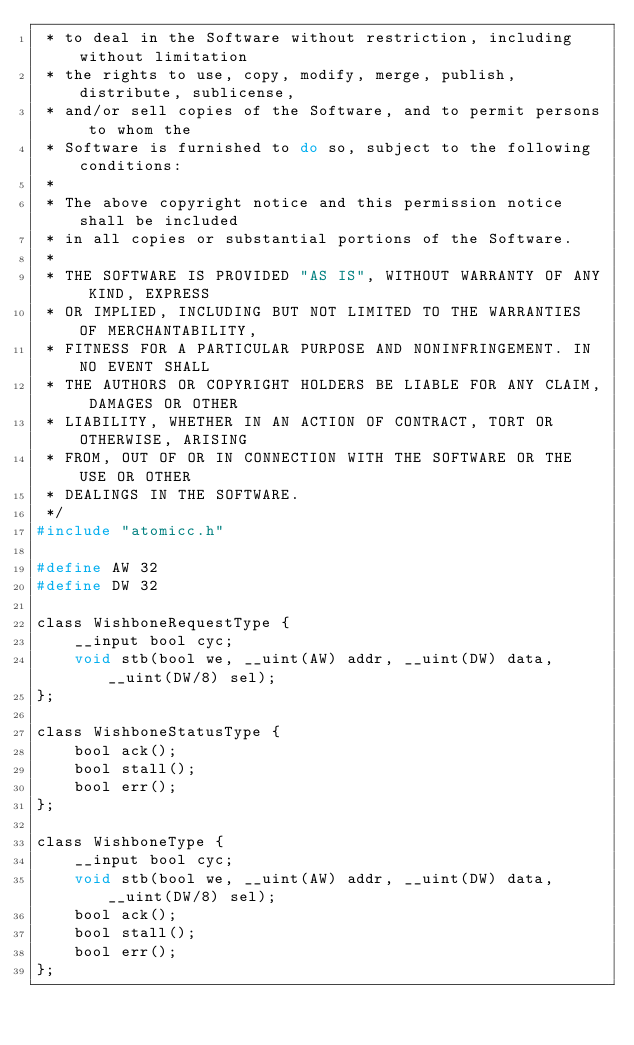<code> <loc_0><loc_0><loc_500><loc_500><_C_> * to deal in the Software without restriction, including without limitation
 * the rights to use, copy, modify, merge, publish, distribute, sublicense,
 * and/or sell copies of the Software, and to permit persons to whom the
 * Software is furnished to do so, subject to the following conditions:
 *
 * The above copyright notice and this permission notice shall be included
 * in all copies or substantial portions of the Software.
 *
 * THE SOFTWARE IS PROVIDED "AS IS", WITHOUT WARRANTY OF ANY KIND, EXPRESS
 * OR IMPLIED, INCLUDING BUT NOT LIMITED TO THE WARRANTIES OF MERCHANTABILITY,
 * FITNESS FOR A PARTICULAR PURPOSE AND NONINFRINGEMENT. IN NO EVENT SHALL
 * THE AUTHORS OR COPYRIGHT HOLDERS BE LIABLE FOR ANY CLAIM, DAMAGES OR OTHER
 * LIABILITY, WHETHER IN AN ACTION OF CONTRACT, TORT OR OTHERWISE, ARISING
 * FROM, OUT OF OR IN CONNECTION WITH THE SOFTWARE OR THE USE OR OTHER
 * DEALINGS IN THE SOFTWARE.
 */
#include "atomicc.h"

#define AW 32
#define DW 32

class WishboneRequestType {
    __input bool cyc;
    void stb(bool we, __uint(AW) addr, __uint(DW) data, __uint(DW/8) sel);
};

class WishboneStatusType {
    bool ack();
    bool stall();
    bool err();
};

class WishboneType {
    __input bool cyc;
    void stb(bool we, __uint(AW) addr, __uint(DW) data, __uint(DW/8) sel);
    bool ack();
    bool stall();
    bool err();
};
</code> 